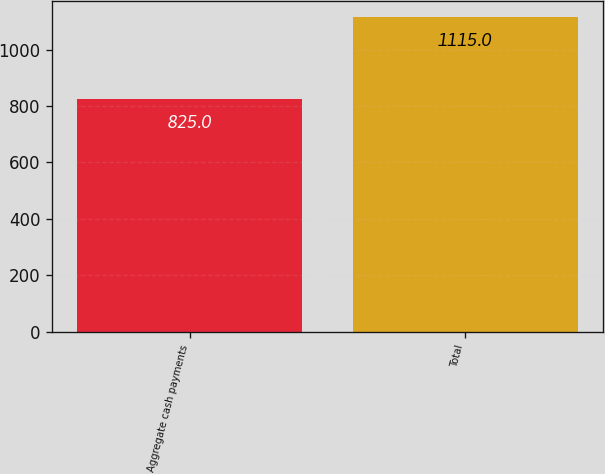Convert chart to OTSL. <chart><loc_0><loc_0><loc_500><loc_500><bar_chart><fcel>Aggregate cash payments<fcel>Total<nl><fcel>825<fcel>1115<nl></chart> 